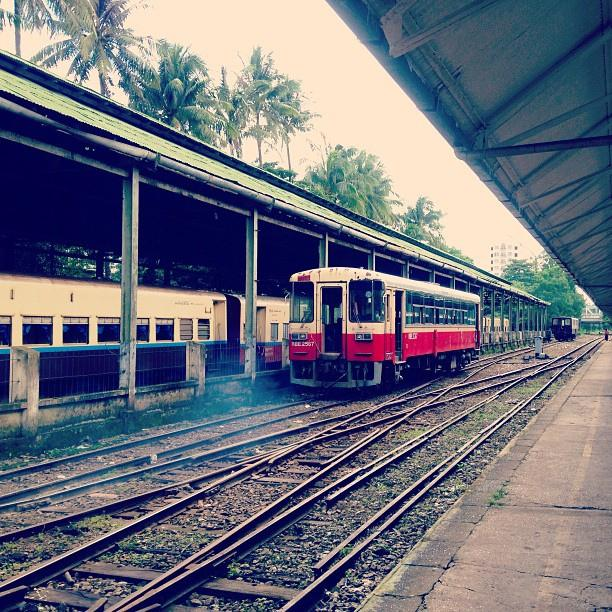Which word best describes this train station? decrepit 